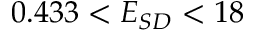Convert formula to latex. <formula><loc_0><loc_0><loc_500><loc_500>0 . 4 3 3 < E _ { S D } < 1 8</formula> 